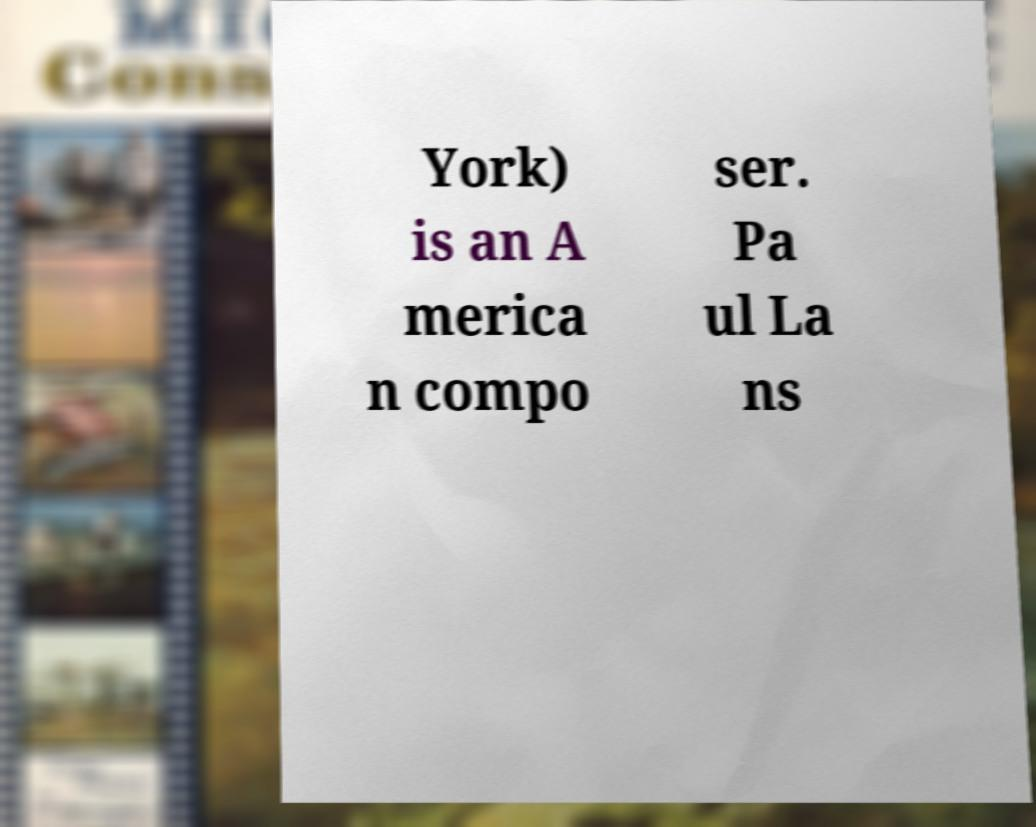Please identify and transcribe the text found in this image. York) is an A merica n compo ser. Pa ul La ns 